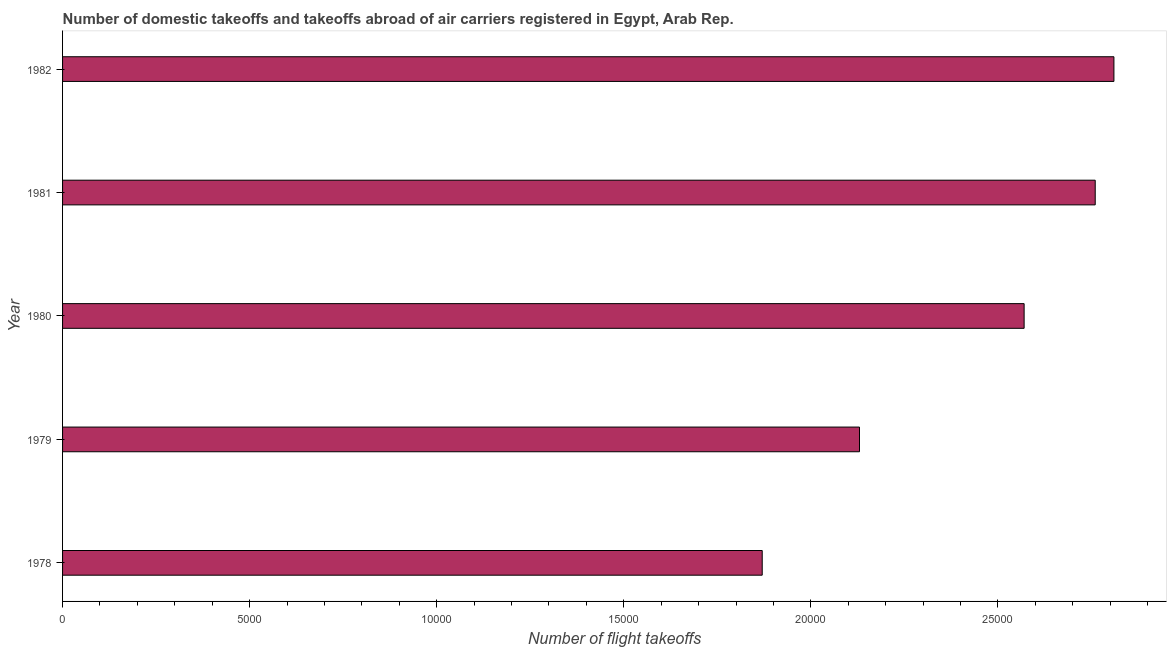Does the graph contain any zero values?
Your answer should be very brief. No. What is the title of the graph?
Your response must be concise. Number of domestic takeoffs and takeoffs abroad of air carriers registered in Egypt, Arab Rep. What is the label or title of the X-axis?
Keep it short and to the point. Number of flight takeoffs. What is the label or title of the Y-axis?
Offer a very short reply. Year. What is the number of flight takeoffs in 1979?
Your answer should be very brief. 2.13e+04. Across all years, what is the maximum number of flight takeoffs?
Your answer should be very brief. 2.81e+04. Across all years, what is the minimum number of flight takeoffs?
Offer a very short reply. 1.87e+04. In which year was the number of flight takeoffs minimum?
Provide a succinct answer. 1978. What is the sum of the number of flight takeoffs?
Keep it short and to the point. 1.21e+05. What is the difference between the number of flight takeoffs in 1978 and 1980?
Make the answer very short. -7000. What is the average number of flight takeoffs per year?
Offer a terse response. 2.43e+04. What is the median number of flight takeoffs?
Make the answer very short. 2.57e+04. In how many years, is the number of flight takeoffs greater than 16000 ?
Give a very brief answer. 5. Do a majority of the years between 1979 and 1981 (inclusive) have number of flight takeoffs greater than 6000 ?
Your answer should be very brief. Yes. What is the ratio of the number of flight takeoffs in 1978 to that in 1982?
Give a very brief answer. 0.67. What is the difference between the highest and the second highest number of flight takeoffs?
Keep it short and to the point. 500. Is the sum of the number of flight takeoffs in 1979 and 1981 greater than the maximum number of flight takeoffs across all years?
Provide a succinct answer. Yes. What is the difference between the highest and the lowest number of flight takeoffs?
Make the answer very short. 9400. In how many years, is the number of flight takeoffs greater than the average number of flight takeoffs taken over all years?
Make the answer very short. 3. What is the Number of flight takeoffs of 1978?
Keep it short and to the point. 1.87e+04. What is the Number of flight takeoffs in 1979?
Your answer should be very brief. 2.13e+04. What is the Number of flight takeoffs in 1980?
Make the answer very short. 2.57e+04. What is the Number of flight takeoffs in 1981?
Offer a very short reply. 2.76e+04. What is the Number of flight takeoffs of 1982?
Keep it short and to the point. 2.81e+04. What is the difference between the Number of flight takeoffs in 1978 and 1979?
Make the answer very short. -2600. What is the difference between the Number of flight takeoffs in 1978 and 1980?
Give a very brief answer. -7000. What is the difference between the Number of flight takeoffs in 1978 and 1981?
Give a very brief answer. -8900. What is the difference between the Number of flight takeoffs in 1978 and 1982?
Ensure brevity in your answer.  -9400. What is the difference between the Number of flight takeoffs in 1979 and 1980?
Keep it short and to the point. -4400. What is the difference between the Number of flight takeoffs in 1979 and 1981?
Give a very brief answer. -6300. What is the difference between the Number of flight takeoffs in 1979 and 1982?
Make the answer very short. -6800. What is the difference between the Number of flight takeoffs in 1980 and 1981?
Give a very brief answer. -1900. What is the difference between the Number of flight takeoffs in 1980 and 1982?
Ensure brevity in your answer.  -2400. What is the difference between the Number of flight takeoffs in 1981 and 1982?
Provide a short and direct response. -500. What is the ratio of the Number of flight takeoffs in 1978 to that in 1979?
Your response must be concise. 0.88. What is the ratio of the Number of flight takeoffs in 1978 to that in 1980?
Give a very brief answer. 0.73. What is the ratio of the Number of flight takeoffs in 1978 to that in 1981?
Make the answer very short. 0.68. What is the ratio of the Number of flight takeoffs in 1978 to that in 1982?
Keep it short and to the point. 0.67. What is the ratio of the Number of flight takeoffs in 1979 to that in 1980?
Your response must be concise. 0.83. What is the ratio of the Number of flight takeoffs in 1979 to that in 1981?
Your answer should be compact. 0.77. What is the ratio of the Number of flight takeoffs in 1979 to that in 1982?
Your answer should be very brief. 0.76. What is the ratio of the Number of flight takeoffs in 1980 to that in 1982?
Make the answer very short. 0.92. 